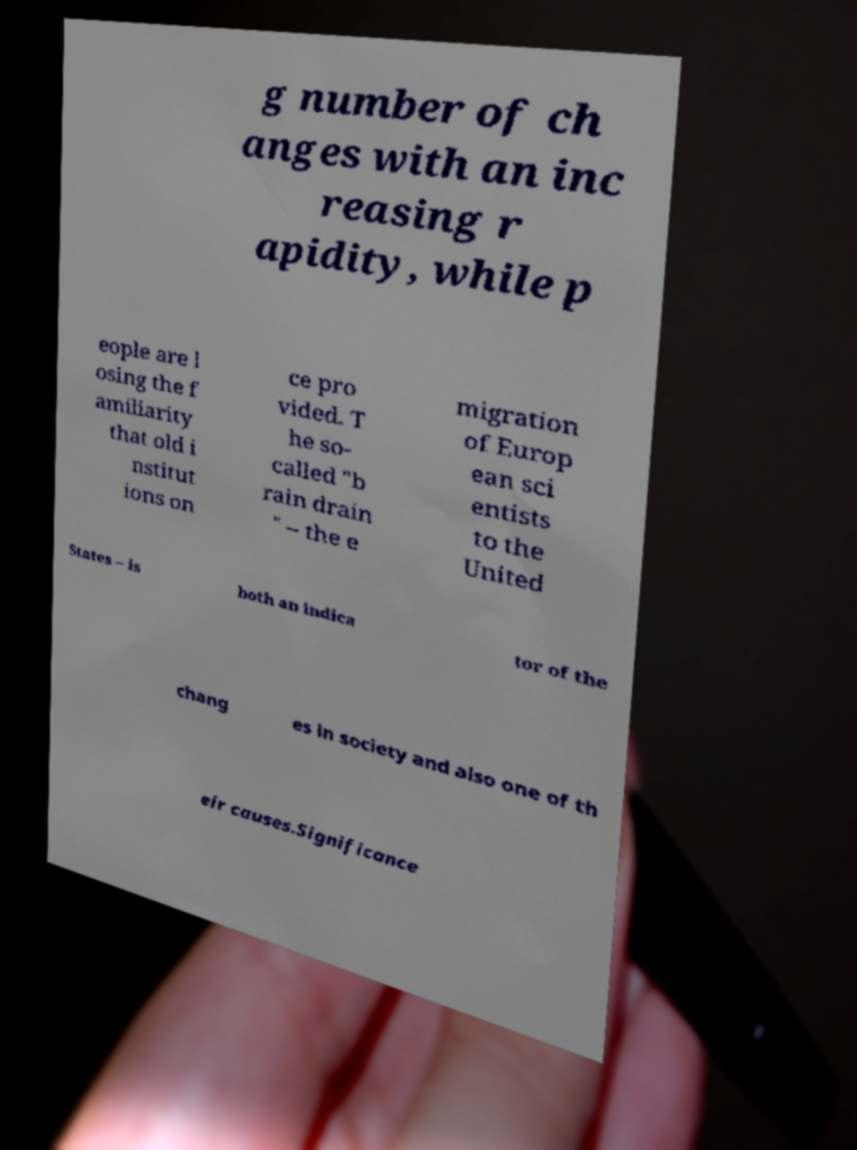I need the written content from this picture converted into text. Can you do that? g number of ch anges with an inc reasing r apidity, while p eople are l osing the f amiliarity that old i nstitut ions on ce pro vided. T he so- called "b rain drain " – the e migration of Europ ean sci entists to the United States – is both an indica tor of the chang es in society and also one of th eir causes.Significance 